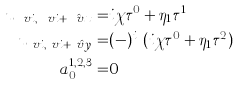Convert formula to latex. <formula><loc_0><loc_0><loc_500><loc_500>u _ { \ v i , \ v i + \hat { \ v x } } = & i \chi \tau ^ { 0 } + \eta _ { 1 } \tau ^ { 1 } \\ u _ { \ v i , \ v i + \hat { \ v y } } = & ( - ) ^ { i _ { x } } ( i \chi \tau ^ { 0 } + \eta _ { 1 } \tau ^ { 2 } ) \\ a ^ { 1 , 2 , 3 } _ { 0 } = & 0</formula> 